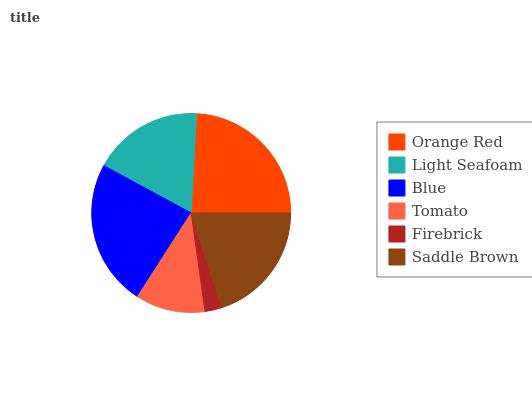Is Firebrick the minimum?
Answer yes or no. Yes. Is Orange Red the maximum?
Answer yes or no. Yes. Is Light Seafoam the minimum?
Answer yes or no. No. Is Light Seafoam the maximum?
Answer yes or no. No. Is Orange Red greater than Light Seafoam?
Answer yes or no. Yes. Is Light Seafoam less than Orange Red?
Answer yes or no. Yes. Is Light Seafoam greater than Orange Red?
Answer yes or no. No. Is Orange Red less than Light Seafoam?
Answer yes or no. No. Is Saddle Brown the high median?
Answer yes or no. Yes. Is Light Seafoam the low median?
Answer yes or no. Yes. Is Tomato the high median?
Answer yes or no. No. Is Orange Red the low median?
Answer yes or no. No. 